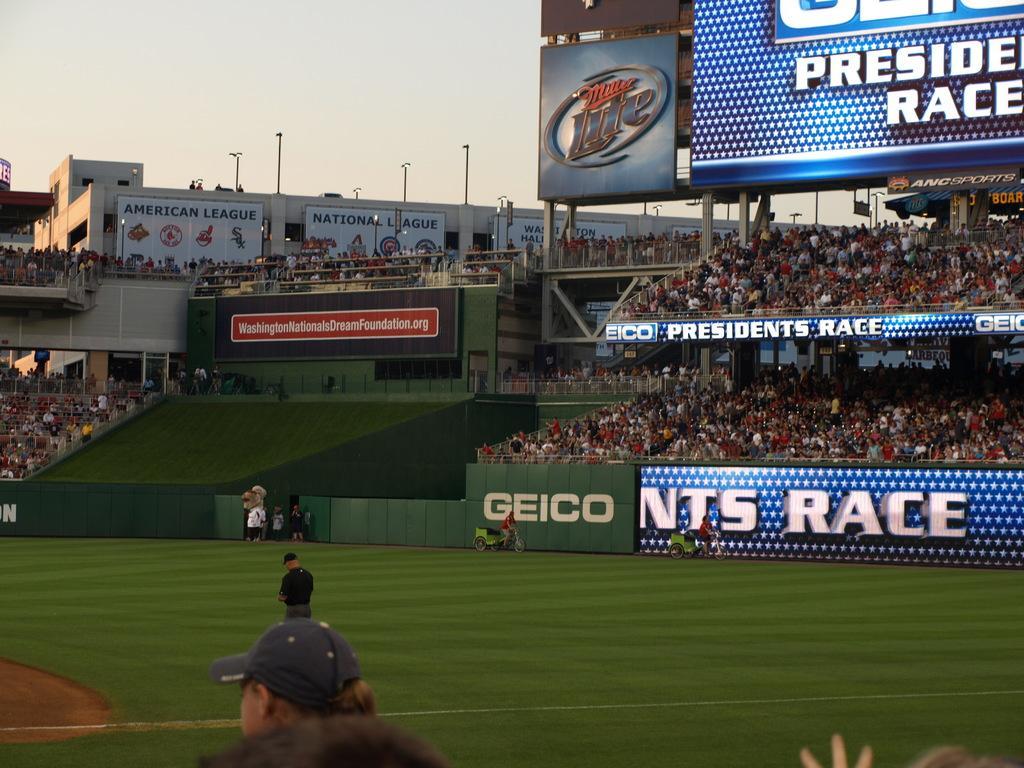In one or two sentences, can you explain what this image depicts? In this image I can see heads of a person's who is wearing a hat, a person wearing black t shirt and black hat is standing on the ground and few other persons. In the background I can see the stadium, number of persons sitting on the stadium, few screens , few poles and the sky. 